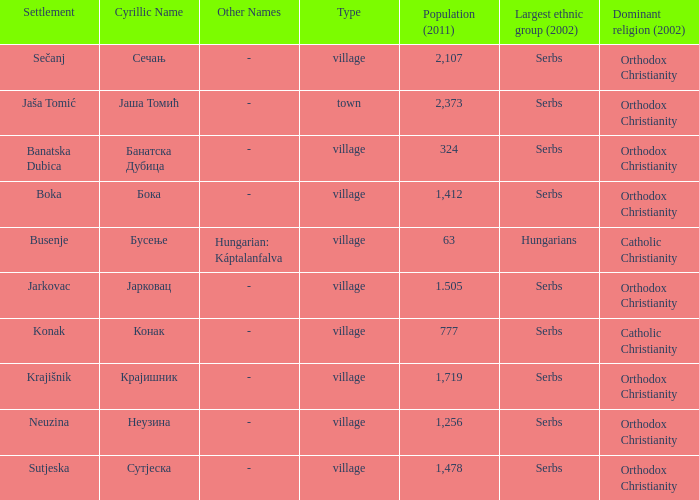The pooulation of јарковац is? 1.505. 